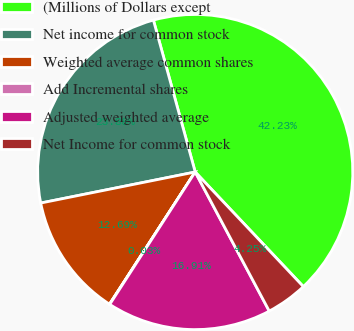Convert chart. <chart><loc_0><loc_0><loc_500><loc_500><pie_chart><fcel>(Millions of Dollars except<fcel>Net income for common stock<fcel>Weighted average common shares<fcel>Add Incremental shares<fcel>Adjusted weighted average<fcel>Net Income for common stock<nl><fcel>42.23%<fcel>23.88%<fcel>12.69%<fcel>0.03%<fcel>16.91%<fcel>4.25%<nl></chart> 